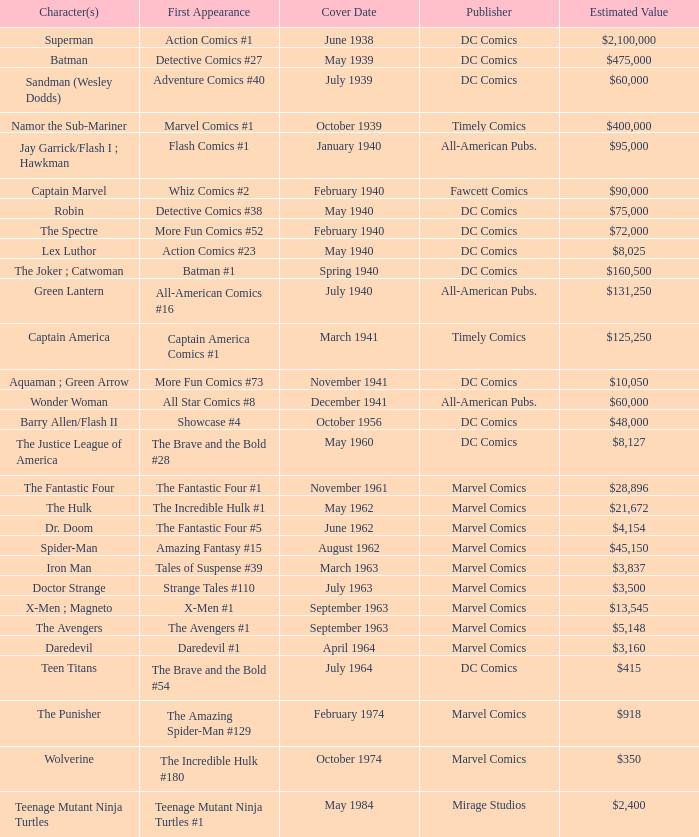Who publishes Wolverine? Marvel Comics. 